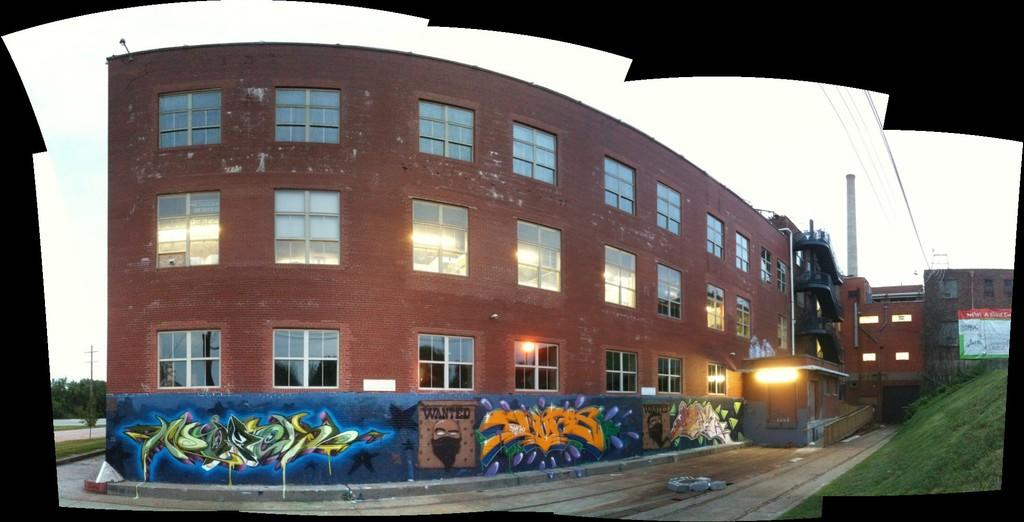What type of structures can be seen in the image? There are buildings in the image. What else is visible in the image besides the buildings? There are lights visible in the image. Where is the pole located in the image? The pole is on the left side of the image. What can be seen in the background of the image? There are trees and the sky visible in the background of the image. How many sheep are grazing in the square in the image? There are no sheep or squares present in the image. 